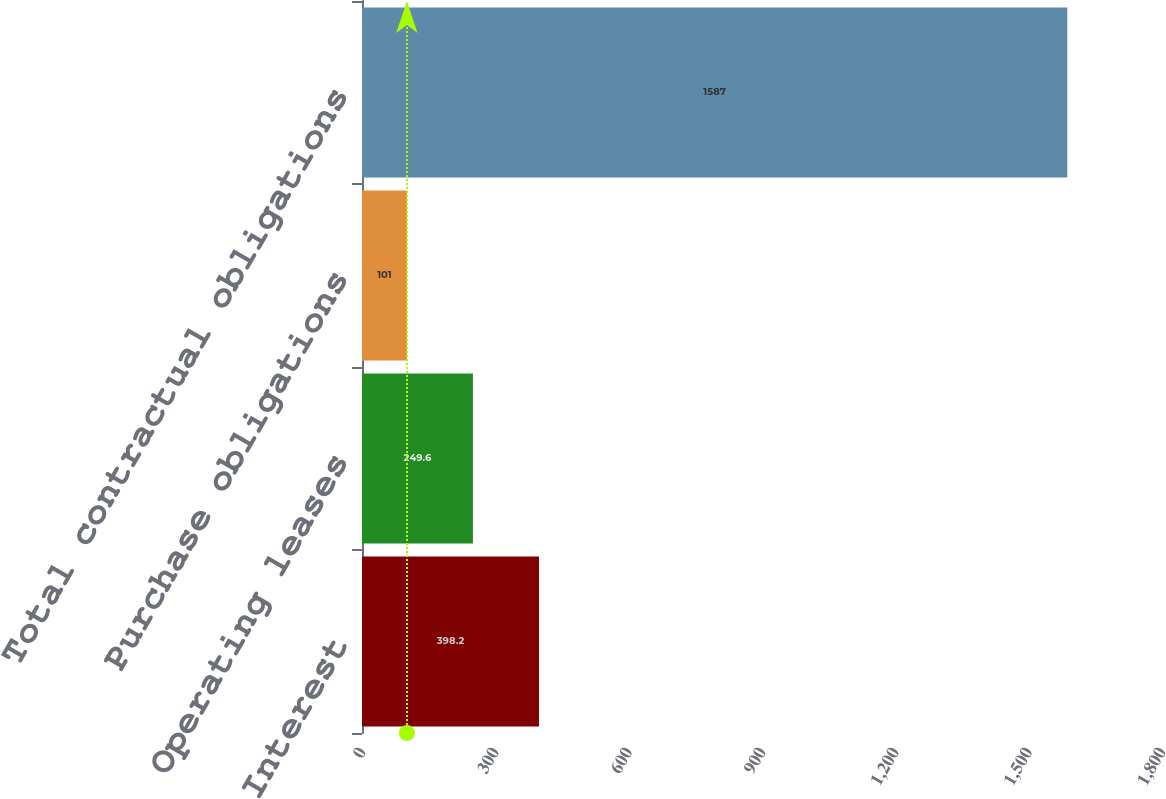Convert chart. <chart><loc_0><loc_0><loc_500><loc_500><bar_chart><fcel>Interest<fcel>Operating leases<fcel>Purchase obligations<fcel>Total contractual obligations<nl><fcel>398.2<fcel>249.6<fcel>101<fcel>1587<nl></chart> 